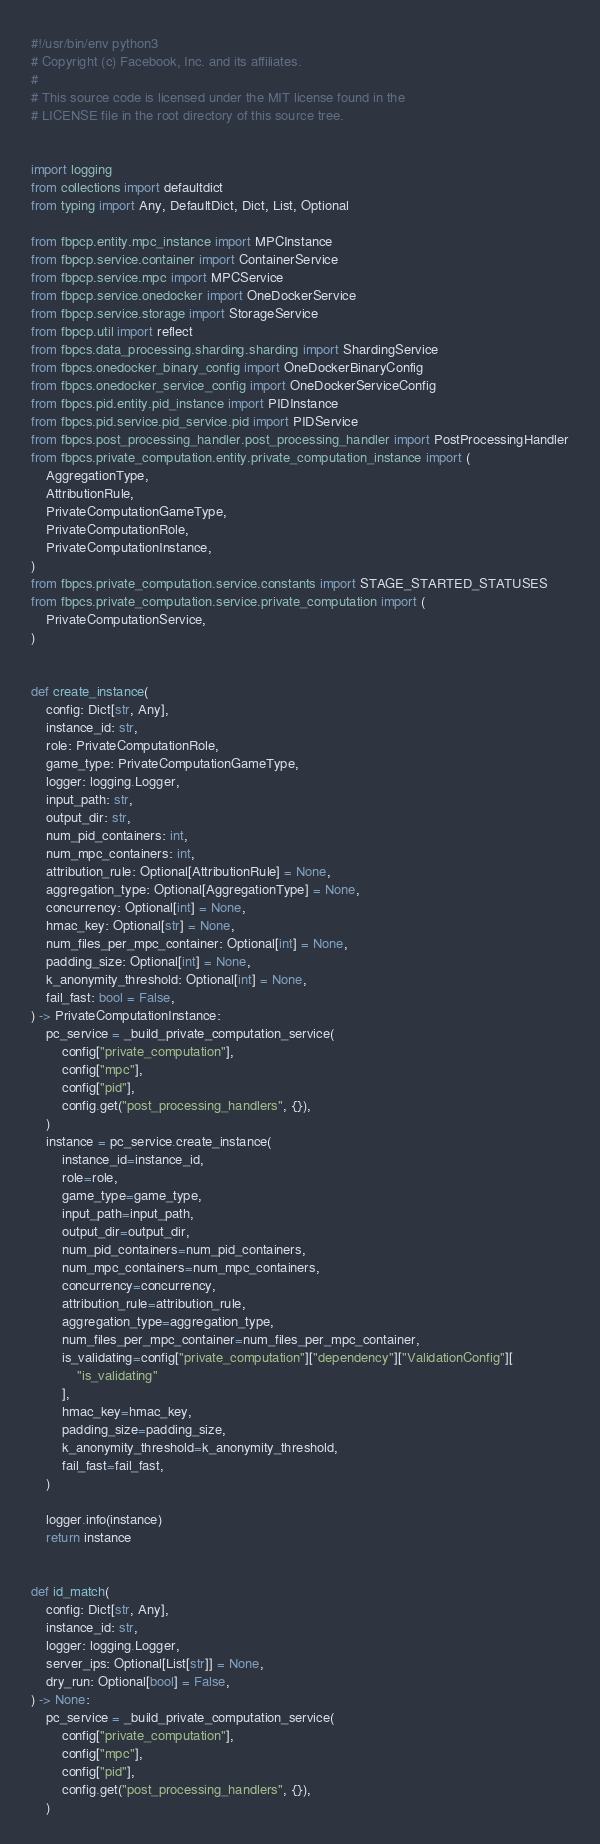<code> <loc_0><loc_0><loc_500><loc_500><_Python_>#!/usr/bin/env python3
# Copyright (c) Facebook, Inc. and its affiliates.
#
# This source code is licensed under the MIT license found in the
# LICENSE file in the root directory of this source tree.


import logging
from collections import defaultdict
from typing import Any, DefaultDict, Dict, List, Optional

from fbpcp.entity.mpc_instance import MPCInstance
from fbpcp.service.container import ContainerService
from fbpcp.service.mpc import MPCService
from fbpcp.service.onedocker import OneDockerService
from fbpcp.service.storage import StorageService
from fbpcp.util import reflect
from fbpcs.data_processing.sharding.sharding import ShardingService
from fbpcs.onedocker_binary_config import OneDockerBinaryConfig
from fbpcs.onedocker_service_config import OneDockerServiceConfig
from fbpcs.pid.entity.pid_instance import PIDInstance
from fbpcs.pid.service.pid_service.pid import PIDService
from fbpcs.post_processing_handler.post_processing_handler import PostProcessingHandler
from fbpcs.private_computation.entity.private_computation_instance import (
    AggregationType,
    AttributionRule,
    PrivateComputationGameType,
    PrivateComputationRole,
    PrivateComputationInstance,
)
from fbpcs.private_computation.service.constants import STAGE_STARTED_STATUSES
from fbpcs.private_computation.service.private_computation import (
    PrivateComputationService,
)


def create_instance(
    config: Dict[str, Any],
    instance_id: str,
    role: PrivateComputationRole,
    game_type: PrivateComputationGameType,
    logger: logging.Logger,
    input_path: str,
    output_dir: str,
    num_pid_containers: int,
    num_mpc_containers: int,
    attribution_rule: Optional[AttributionRule] = None,
    aggregation_type: Optional[AggregationType] = None,
    concurrency: Optional[int] = None,
    hmac_key: Optional[str] = None,
    num_files_per_mpc_container: Optional[int] = None,
    padding_size: Optional[int] = None,
    k_anonymity_threshold: Optional[int] = None,
    fail_fast: bool = False,
) -> PrivateComputationInstance:
    pc_service = _build_private_computation_service(
        config["private_computation"],
        config["mpc"],
        config["pid"],
        config.get("post_processing_handlers", {}),
    )
    instance = pc_service.create_instance(
        instance_id=instance_id,
        role=role,
        game_type=game_type,
        input_path=input_path,
        output_dir=output_dir,
        num_pid_containers=num_pid_containers,
        num_mpc_containers=num_mpc_containers,
        concurrency=concurrency,
        attribution_rule=attribution_rule,
        aggregation_type=aggregation_type,
        num_files_per_mpc_container=num_files_per_mpc_container,
        is_validating=config["private_computation"]["dependency"]["ValidationConfig"][
            "is_validating"
        ],
        hmac_key=hmac_key,
        padding_size=padding_size,
        k_anonymity_threshold=k_anonymity_threshold,
        fail_fast=fail_fast,
    )

    logger.info(instance)
    return instance


def id_match(
    config: Dict[str, Any],
    instance_id: str,
    logger: logging.Logger,
    server_ips: Optional[List[str]] = None,
    dry_run: Optional[bool] = False,
) -> None:
    pc_service = _build_private_computation_service(
        config["private_computation"],
        config["mpc"],
        config["pid"],
        config.get("post_processing_handlers", {}),
    )
</code> 